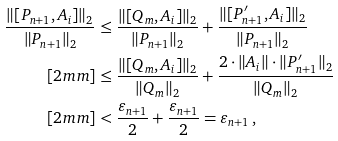Convert formula to latex. <formula><loc_0><loc_0><loc_500><loc_500>\frac { \| [ P _ { n + 1 } , A _ { i } ] \| _ { 2 } } { \| P _ { n + 1 } \| _ { 2 } } & \leq \frac { \| [ Q _ { m } , A _ { i } ] \| _ { 2 } } { \| P _ { n + 1 } \| _ { 2 } } + \frac { \| [ P ^ { \prime } _ { n + 1 } , A _ { i } ] \| _ { 2 } } { \| P _ { n + 1 } \| _ { 2 } } \\ [ 2 m m ] & \leq \frac { \| [ Q _ { m } , A _ { i } ] \| _ { 2 } } { \| Q _ { m } \| _ { 2 } } + \frac { 2 \cdot \| A _ { i } \| \cdot \| P ^ { \prime } _ { n + 1 } \| _ { 2 } } { \| Q _ { m } \| _ { 2 } } \\ [ 2 m m ] & < \frac { \varepsilon _ { n + 1 } } { 2 } + \frac { \varepsilon _ { n + 1 } } { 2 } = \varepsilon _ { n + 1 } \, ,</formula> 